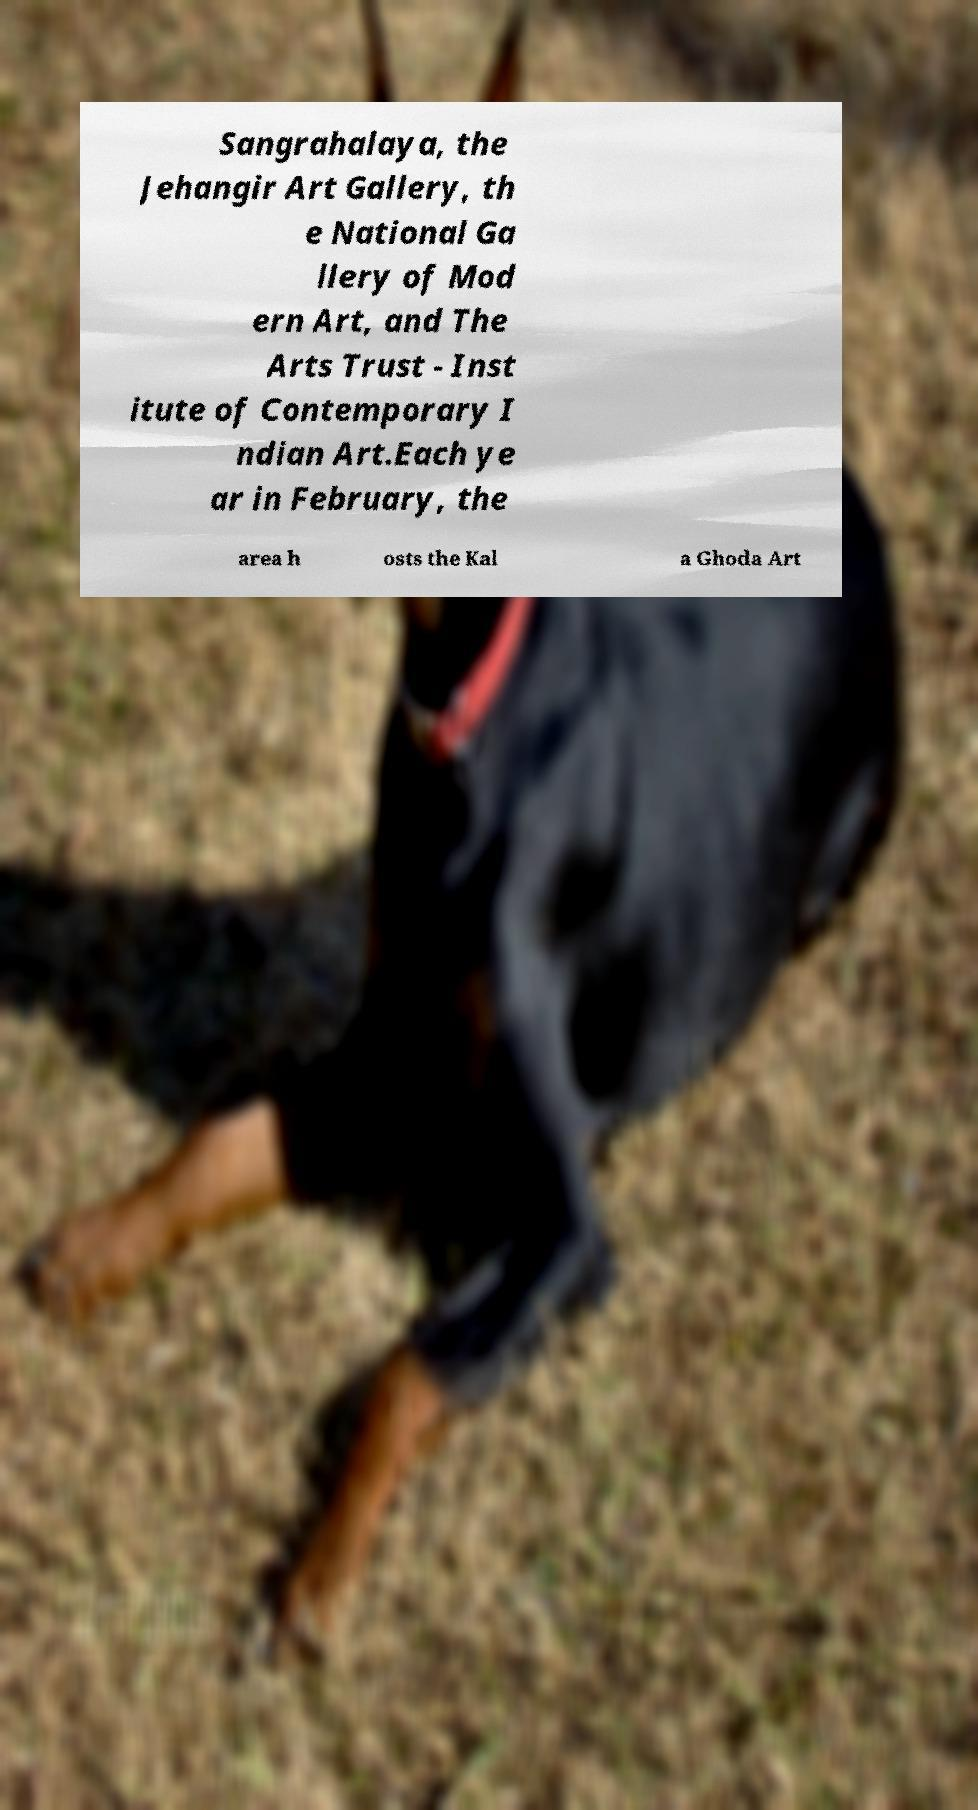Can you read and provide the text displayed in the image?This photo seems to have some interesting text. Can you extract and type it out for me? Sangrahalaya, the Jehangir Art Gallery, th e National Ga llery of Mod ern Art, and The Arts Trust - Inst itute of Contemporary I ndian Art.Each ye ar in February, the area h osts the Kal a Ghoda Art 